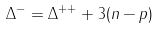Convert formula to latex. <formula><loc_0><loc_0><loc_500><loc_500>\Delta ^ { - } = \Delta ^ { + + } + 3 ( n - p )</formula> 